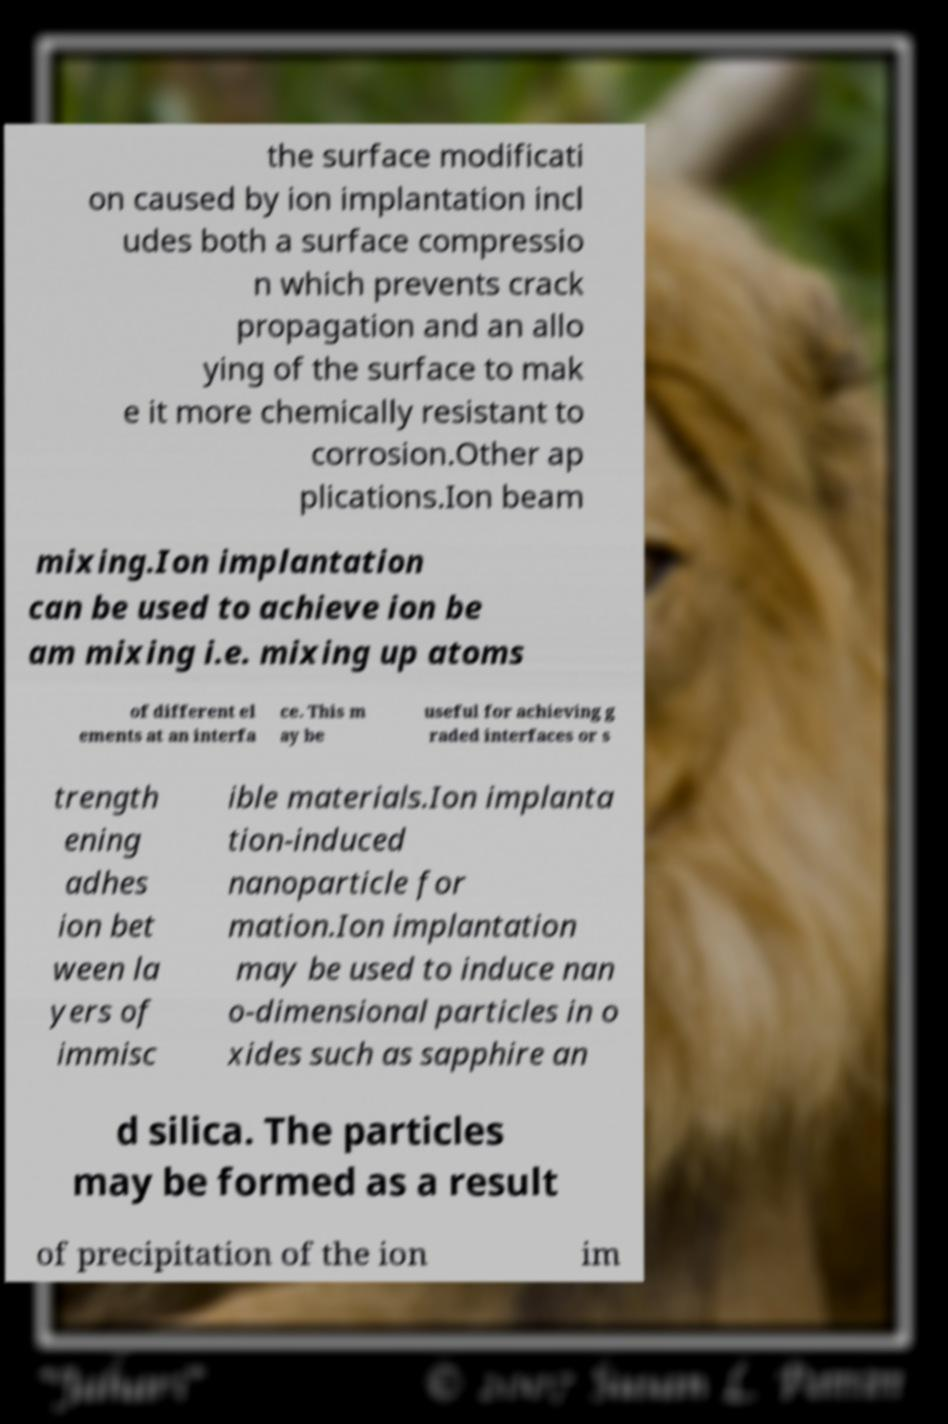Can you accurately transcribe the text from the provided image for me? the surface modificati on caused by ion implantation incl udes both a surface compressio n which prevents crack propagation and an allo ying of the surface to mak e it more chemically resistant to corrosion.Other ap plications.Ion beam mixing.Ion implantation can be used to achieve ion be am mixing i.e. mixing up atoms of different el ements at an interfa ce. This m ay be useful for achieving g raded interfaces or s trength ening adhes ion bet ween la yers of immisc ible materials.Ion implanta tion-induced nanoparticle for mation.Ion implantation may be used to induce nan o-dimensional particles in o xides such as sapphire an d silica. The particles may be formed as a result of precipitation of the ion im 